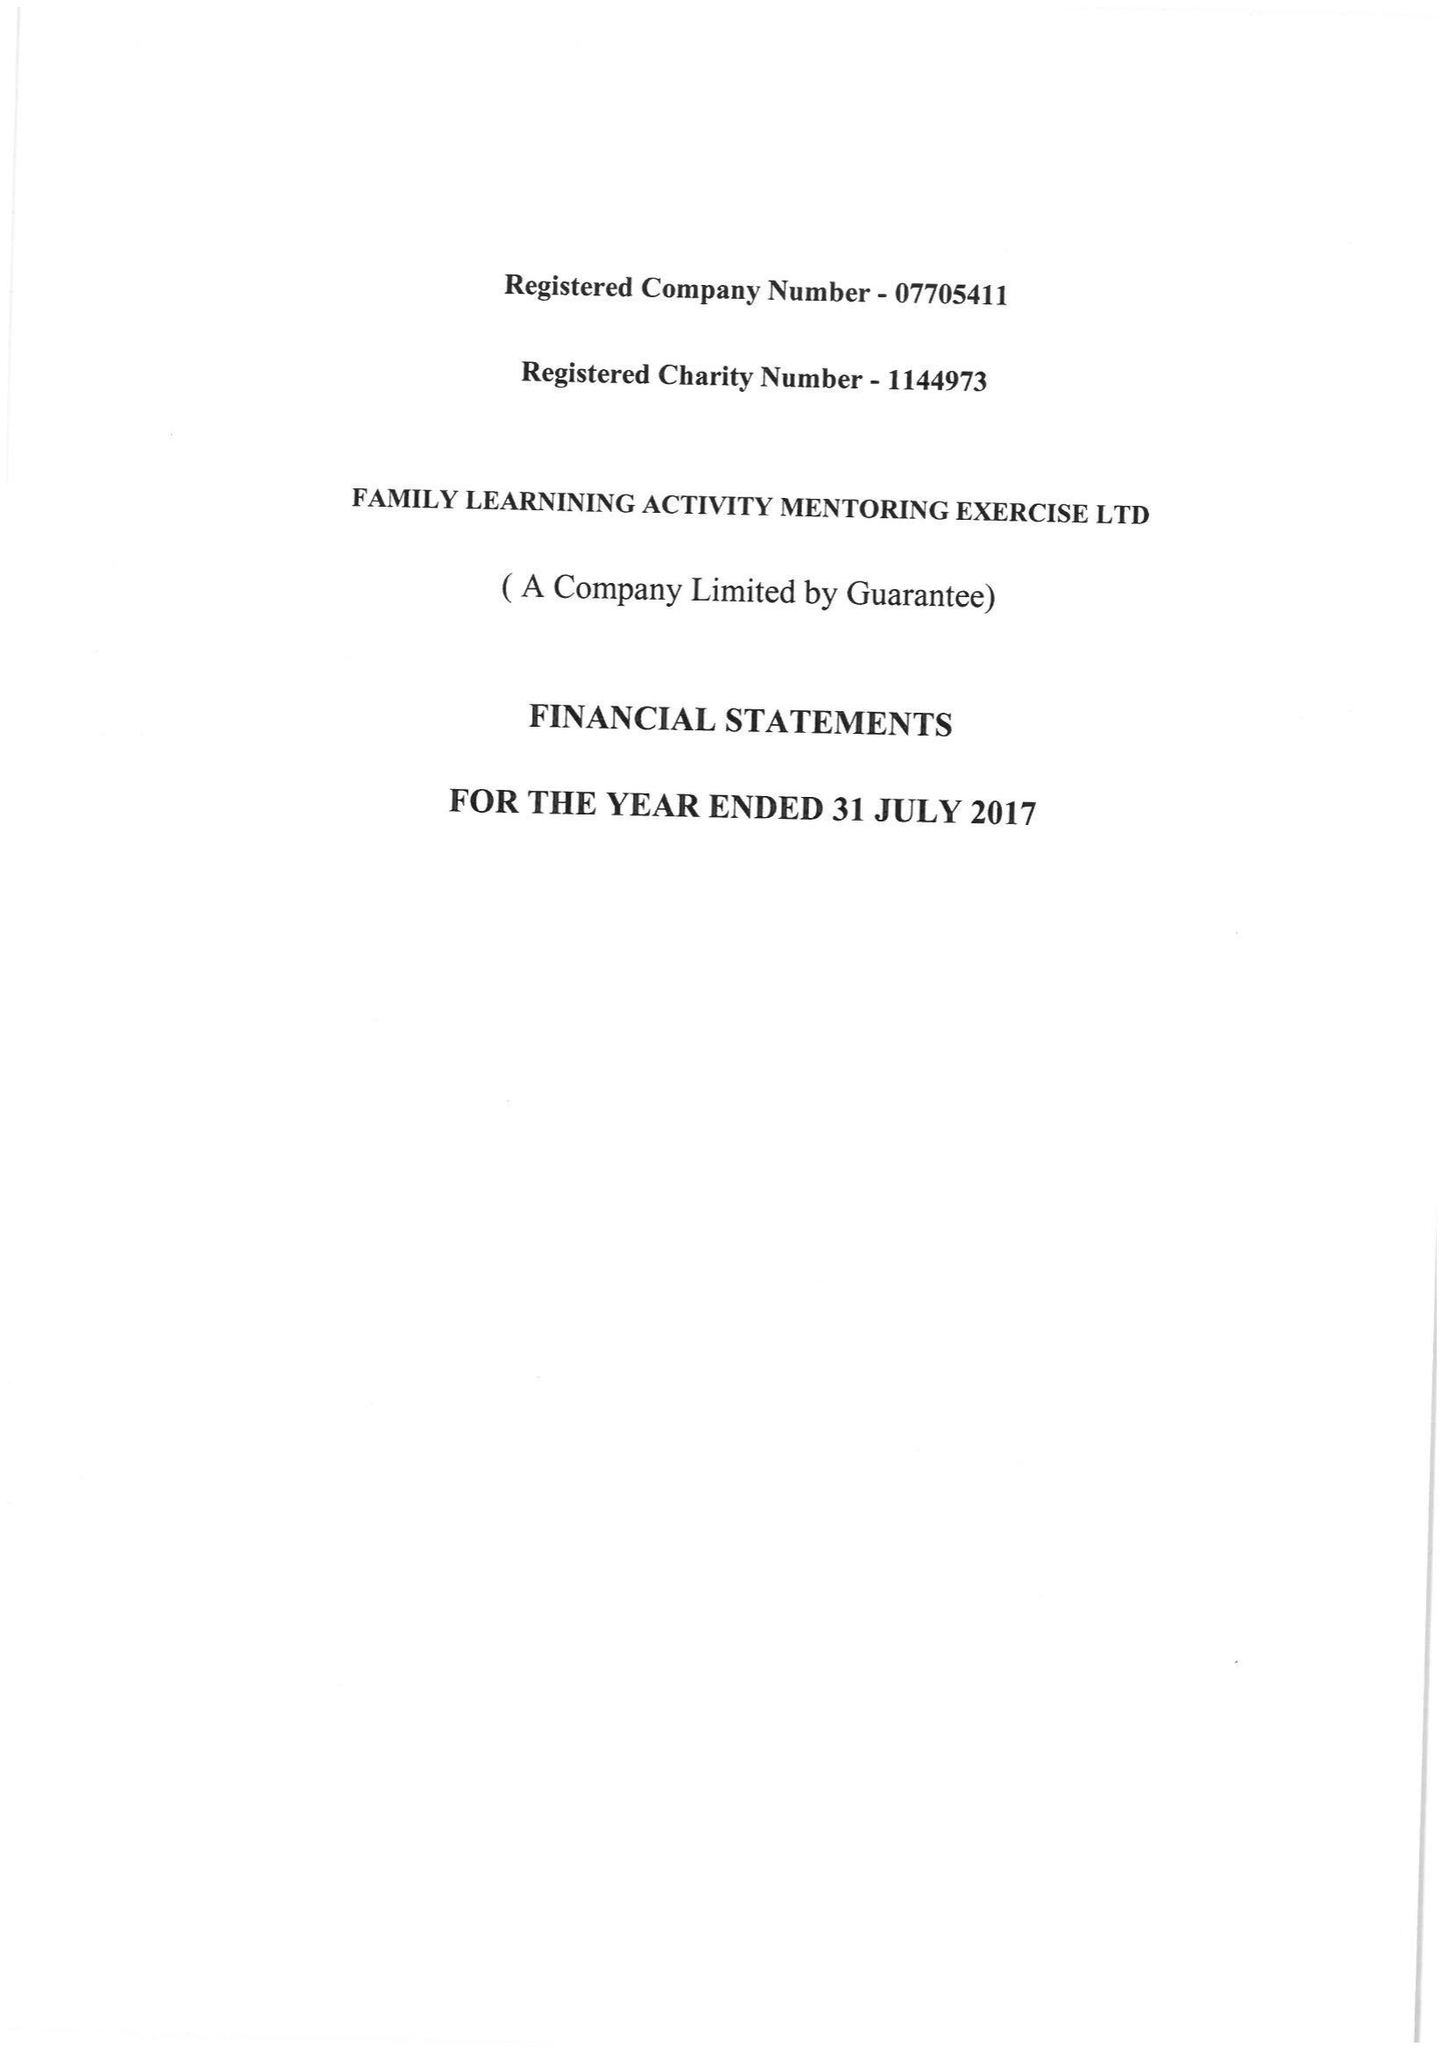What is the value for the charity_name?
Answer the question using a single word or phrase. Family Learning Activity Mentoring and Exercise 